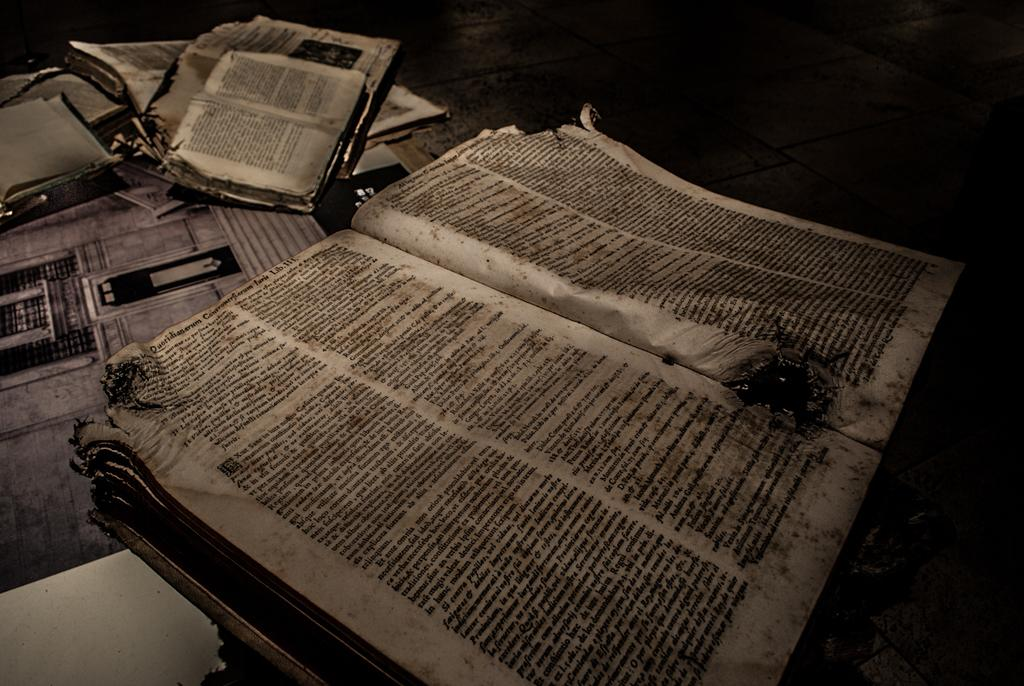<image>
Render a clear and concise summary of the photo. Books that look damaged are opened and the last word at the top of the left page says LIB.111. 